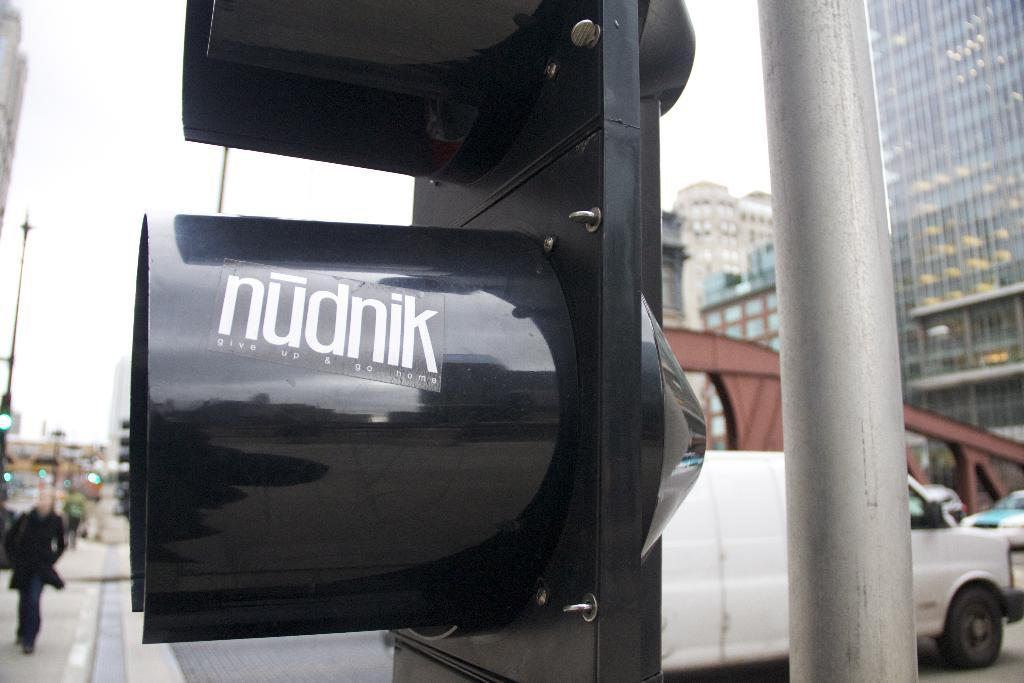<image>
Render a clear and concise summary of the photo. A black post with a sticker on it from Nudnik. 